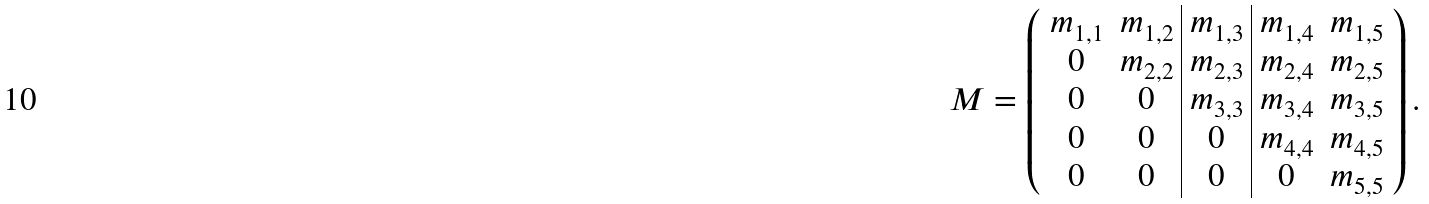Convert formula to latex. <formula><loc_0><loc_0><loc_500><loc_500>M & = \left ( \begin{array} { c c | c | c c } m _ { 1 , 1 } & m _ { 1 , 2 } & m _ { 1 , 3 } & m _ { 1 , 4 } & m _ { 1 , 5 } \\ 0 & m _ { 2 , 2 } & m _ { 2 , 3 } & m _ { 2 , 4 } & m _ { 2 , 5 } \\ 0 & 0 & m _ { 3 , 3 } & m _ { 3 , 4 } & m _ { 3 , 5 } \\ 0 & 0 & 0 & m _ { 4 , 4 } & m _ { 4 , 5 } \\ 0 & 0 & 0 & 0 & m _ { 5 , 5 } \end{array} \right ) .</formula> 